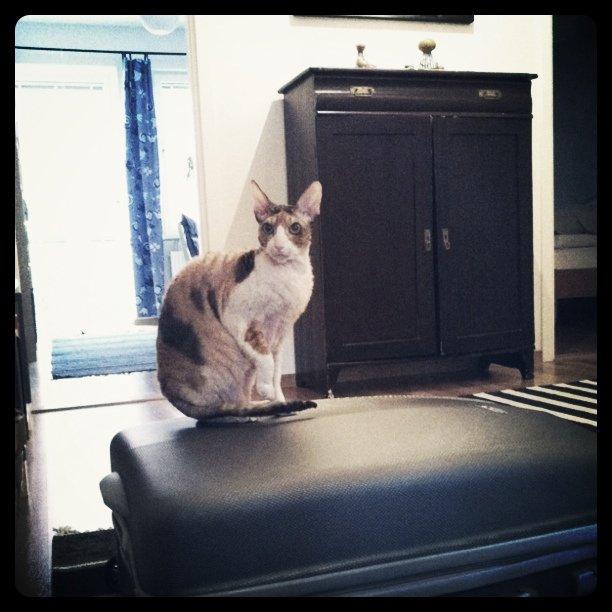What is the animal sitting on?
Keep it brief. Suitcase. Does the cat have floppy ears?
Be succinct. No. Is this a kangaroo?
Write a very short answer. No. Is the door closed?
Write a very short answer. No. 